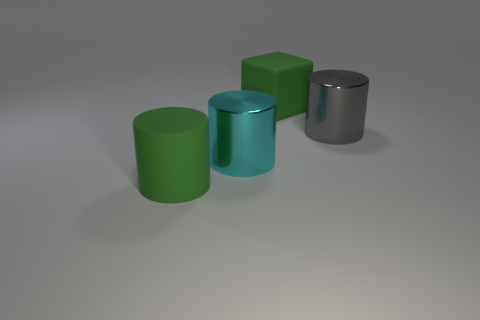Subtract all big cyan metallic cylinders. How many cylinders are left? 2 Add 3 big yellow metal cylinders. How many objects exist? 7 Subtract all gray cylinders. How many cylinders are left? 2 Subtract 0 yellow balls. How many objects are left? 4 Subtract all cubes. How many objects are left? 3 Subtract 2 cylinders. How many cylinders are left? 1 Subtract all yellow cylinders. Subtract all yellow blocks. How many cylinders are left? 3 Subtract all red cubes. How many cyan cylinders are left? 1 Subtract all purple rubber balls. Subtract all large cyan cylinders. How many objects are left? 3 Add 1 large cyan metallic cylinders. How many large cyan metallic cylinders are left? 2 